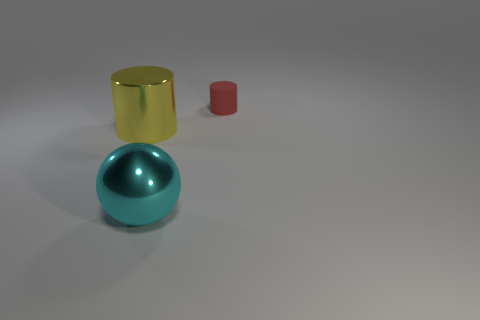What materials do the objects appear to be made from? The sphere and the taller cylinder have a reflective surface suggestive of polished metal, likely indicative of steel or aluminum. The smaller cylinder's matte texture suggests it could be made of plastic or painted metal. 